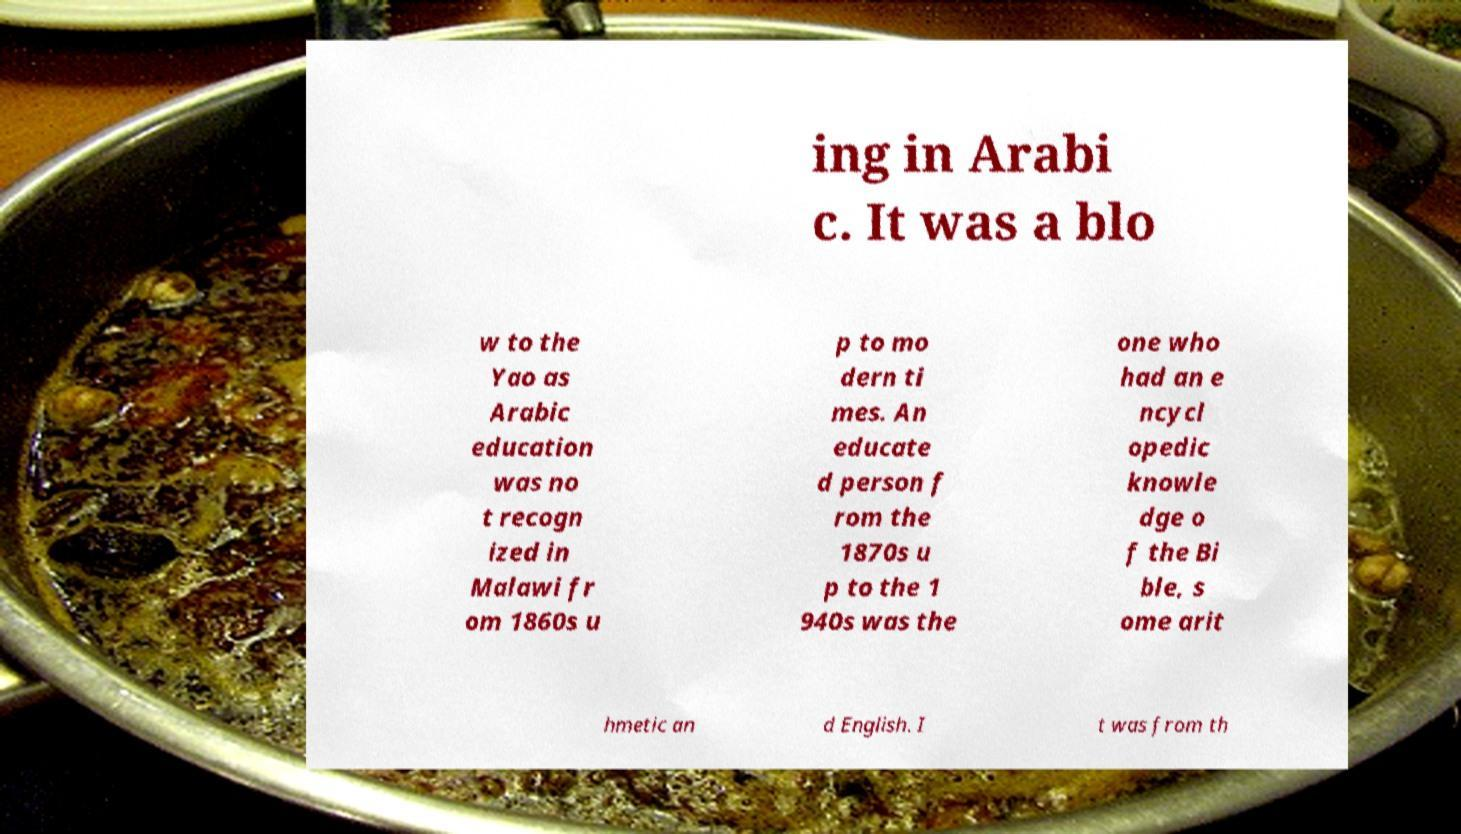Can you accurately transcribe the text from the provided image for me? ing in Arabi c. It was a blo w to the Yao as Arabic education was no t recogn ized in Malawi fr om 1860s u p to mo dern ti mes. An educate d person f rom the 1870s u p to the 1 940s was the one who had an e ncycl opedic knowle dge o f the Bi ble, s ome arit hmetic an d English. I t was from th 